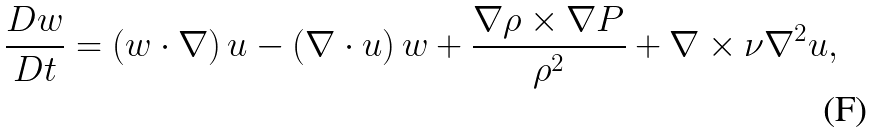<formula> <loc_0><loc_0><loc_500><loc_500>\frac { D { w } } { D t } = \left ( { w } \cdot \nabla \right ) { u } - \left ( \nabla \cdot { u } \right ) { w } + \frac { \nabla \rho \times \nabla P } { \rho ^ { 2 } } + \nabla \times \nu \nabla ^ { 2 } { u } ,</formula> 